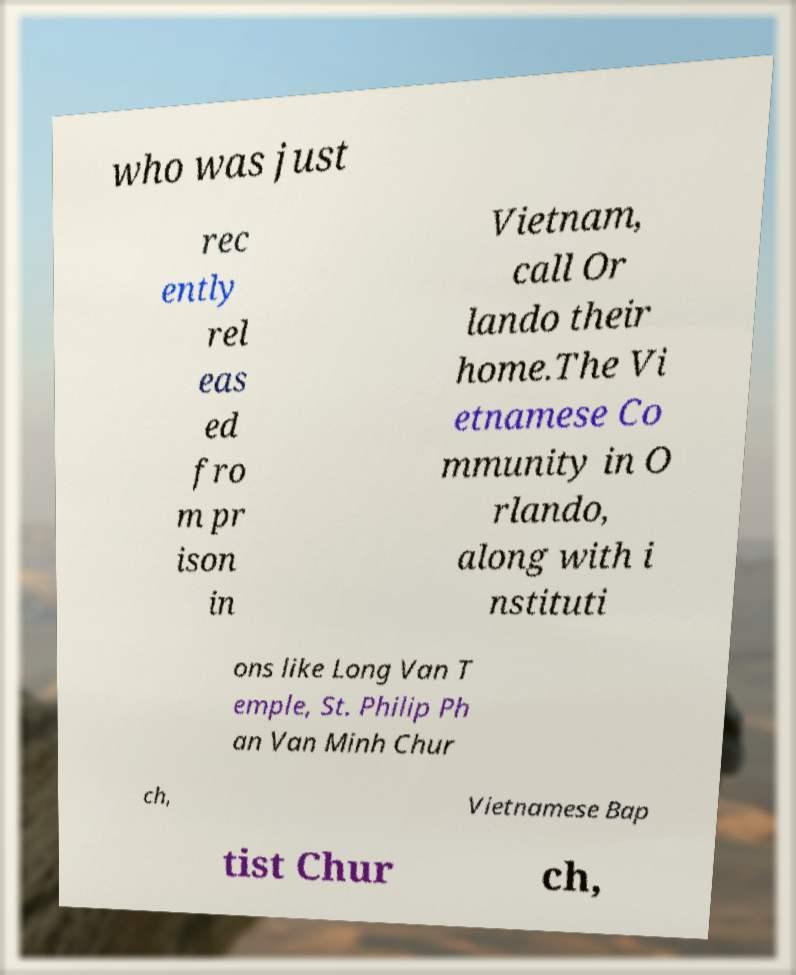Could you assist in decoding the text presented in this image and type it out clearly? who was just rec ently rel eas ed fro m pr ison in Vietnam, call Or lando their home.The Vi etnamese Co mmunity in O rlando, along with i nstituti ons like Long Van T emple, St. Philip Ph an Van Minh Chur ch, Vietnamese Bap tist Chur ch, 